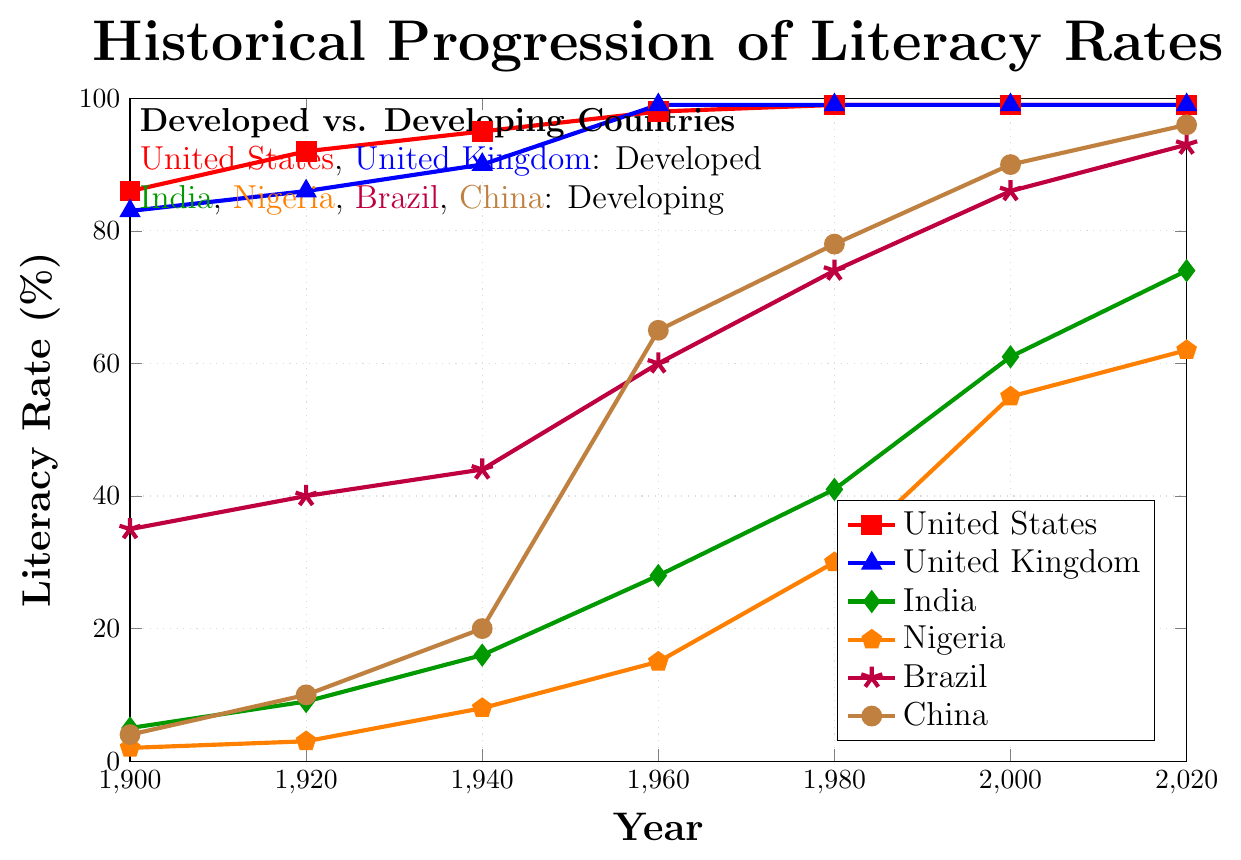what is the literacy rate of the United States in 1920? The figure shows the progression of literacy rates in different countries. To find the literacy rate of the United States in 1920, locate the United States line and find the corresponding point in 1920.
Answer: 92% How did the literacy rate of India change from 1900 to 2020? Examine the line representing India in the figure. Note the literacy rate in 1900 and 2020. The rate increased from 5% in 1900 to 74% in 2020.
Answer: increased by 69% Which country had the lowest literacy rate in 1940? Compare the points for all countries in 1940. The country with the lowest point is Nigeria.
Answer: Nigeria Among the developed countries (United States and United Kingdom), which one reached a 99% literacy rate first? Compare the two lines representing developed countries. UK reached 99% in 1960, followed by the US in 1980.
Answer: United Kingdom What is the average literacy rate of Brazil across all the years shown? Calculate the average by summing Brazil's literacy rates (35, 40, 44, 60, 74, 86, 93) and dividing by the number of data points (7). The sum is 432, and the average is 432/7 = 61.7 (approximately).
Answer: 61.7% Compare the literacy rate increases of China and India from 1900 to 1960. Which country experienced a higher increase? Note the change for China (1960 rate 65% - 1900 rate 4% = 61%) and India (1960 rate 28% - 1900 rate 5% = 23%). China experienced a higher increase.
Answer: China In 2020, which developing country had the highest literacy rate? Examine the 2020 data points for developing countries (India, Nigeria, Brazil, China). China had the highest rate at 96%.
Answer: China Which country showed the most significant improvement in literacy rates between 1980 and 2000? Calculate the increase for each country between 1980 and 2000. India: 61-41=20, Nigeria: 55-30=25, Brazil: 86-74=12, China: 90-78=12. Nigeria had the most significant improvement.
Answer: Nigeria How many countries achieved a literacy rate of at least 50% by 1960? Check the literacy rates in 1960. The countries with rates 50% or higher are Brazil and China. Only two countries achieved this.
Answer: 2 What is the difference in literacy rates between Brazil and China in 1940? Locate the 1940 rates for both countries. Brazil: 44%, China: 20%. The difference is 44% - 20% = 24%.
Answer: 24% 